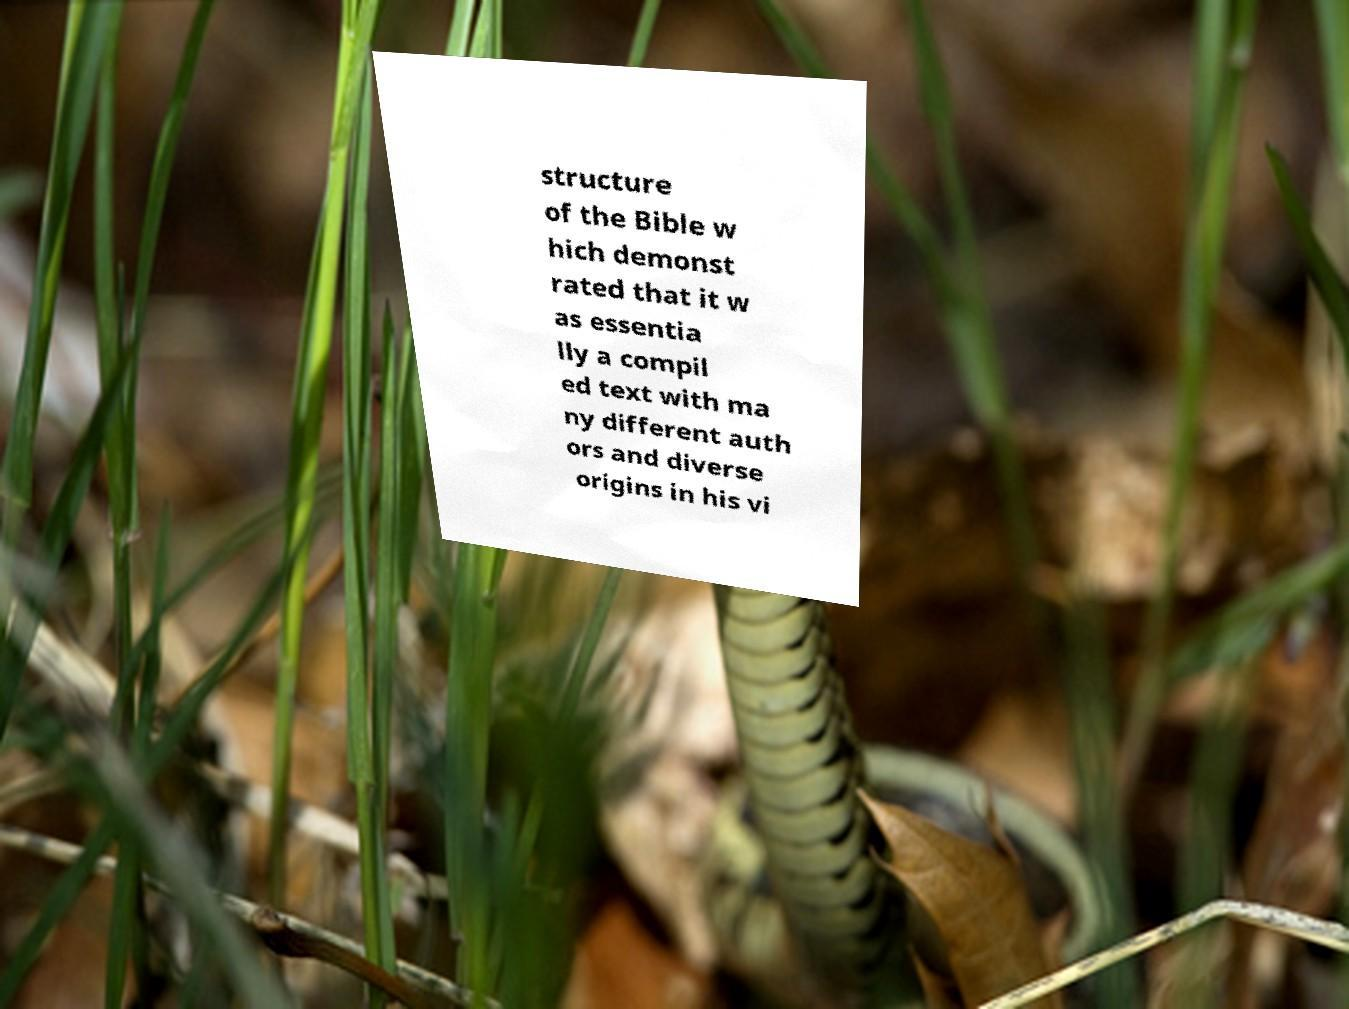Could you assist in decoding the text presented in this image and type it out clearly? structure of the Bible w hich demonst rated that it w as essentia lly a compil ed text with ma ny different auth ors and diverse origins in his vi 